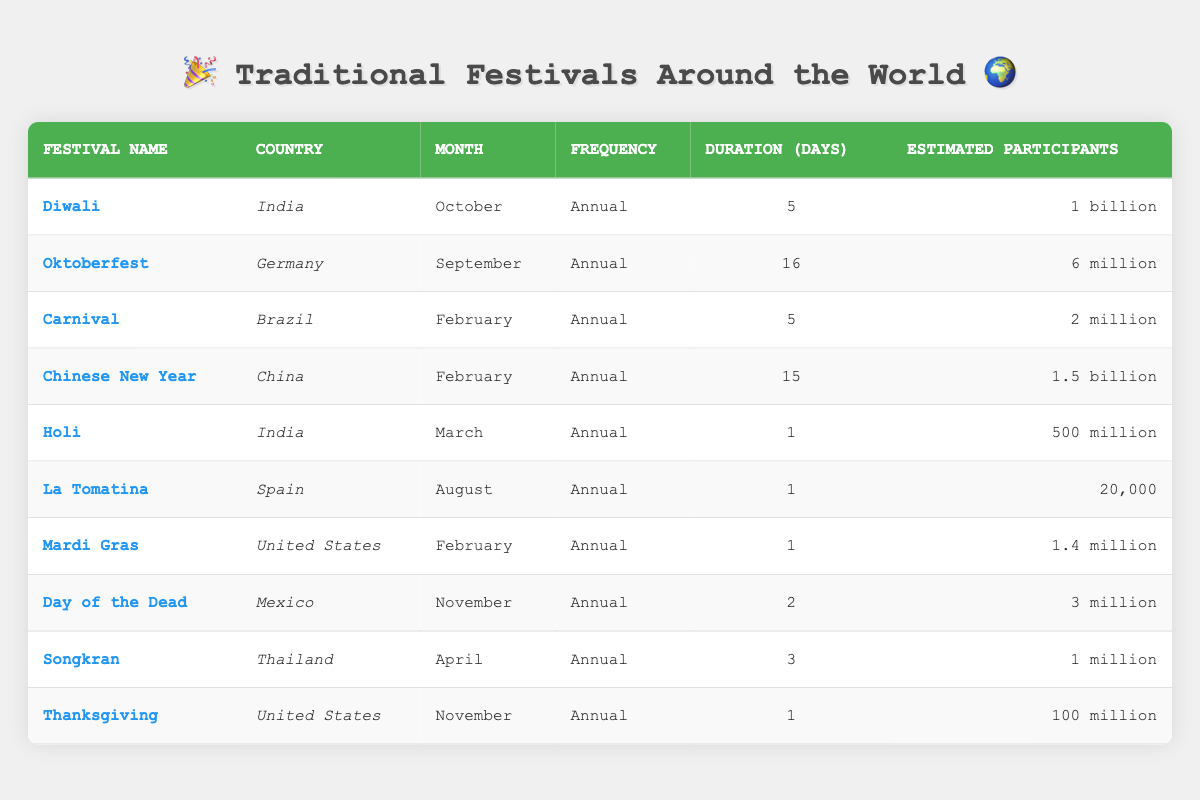What is the estimated number of participants in Diwali? Diwali, which is celebrated in India, has an estimated participants estimate of "1 billion" as listed in the table.
Answer: 1 billion In which month does Carnival occur? According to the table, Carnival is celebrated in Brazil in the month of February.
Answer: February How many days does Oktoberfest last? The table shows that Oktoberfest, which takes place in Germany, lasts for 16 days.
Answer: 16 days Which festival has the highest estimated number of participants? By examining the estimated participants for each festival, Chinese New Year has the highest number with approximately 1.5 billion participants.
Answer: Chinese New Year True or False: Holi is an annual festival celebrated in April. The table indicates that Holi is celebrated annually in March, not April, hence the statement is false.
Answer: False What is the total estimated number of participants for festivals celebrated in the United States? The estimates for festivals in the United States are Thanksgiving (100 million) and Mardi Gras (1.4 million). Adding these together gives 100 million + 1.4 million = 101.4 million.
Answer: 101.4 million Is La Tomatina celebrated in August or September? According to the table, La Tomatina is celebrated in August, confirming the statement as true.
Answer: August Which festival lasts the shortest duration and what is it? Reviewing the durations, both La Tomatina and Holi last for 1 day, making them the shortest.
Answer: La Tomatina and Holi What is the median duration of the festivals listed? The durations are 5, 16, 5, 15, 1, 1, 1, 2, 3, and 1. Arranging them gives: 1, 1, 1, 1, 2, 3, 5, 5, 15, 16. The median (middle value) is the average of the 5th and 6th values: (2 + 3)/2 = 2.5.
Answer: 2.5 days 